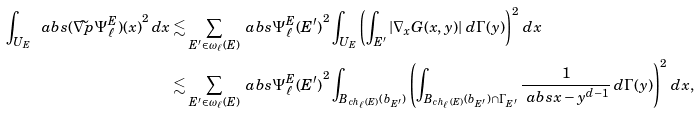<formula> <loc_0><loc_0><loc_500><loc_500>\int _ { U _ { E } } \ a b s { ( \nabla \widetilde { \sl } p \Psi _ { \ell } ^ { E } ) ( x ) } ^ { 2 } \, d x & \lesssim \sum _ { E ^ { \prime } \in \omega _ { \ell } ( E ) } \ a b s { \Psi _ { \ell } ^ { E } ( E ^ { \prime } ) } ^ { 2 } \int _ { U _ { E } } \left ( \int _ { E ^ { \prime } } \left | \nabla _ { x } G ( x , y ) \right | \, d \Gamma ( y ) \right ) ^ { 2 } \, d x \\ & \lesssim \sum _ { E ^ { \prime } \in \omega _ { \ell } ( E ) } \ a b s { \Psi _ { \ell } ^ { E } ( E ^ { \prime } ) } ^ { 2 } \int _ { B _ { c h _ { \ell } ( E ) } ( b _ { E ^ { \prime } } ) } \left ( \int _ { B _ { c h _ { \ell } ( E ) } ( b _ { E ^ { \prime } } ) \cap \Gamma _ { E ^ { \prime } } } \frac { 1 } { \ a b s { x - y } ^ { d - 1 } } \, d \Gamma ( y ) \right ) ^ { 2 } \, d x ,</formula> 